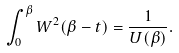<formula> <loc_0><loc_0><loc_500><loc_500>\int _ { 0 } ^ { \beta } W ^ { 2 } ( \beta - t ) = \frac { 1 } { U ( \beta ) } .</formula> 